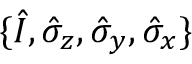<formula> <loc_0><loc_0><loc_500><loc_500>\{ \hat { I } , \hat { \sigma } _ { z } , \hat { \sigma } _ { y } , \hat { \sigma } _ { x } \}</formula> 